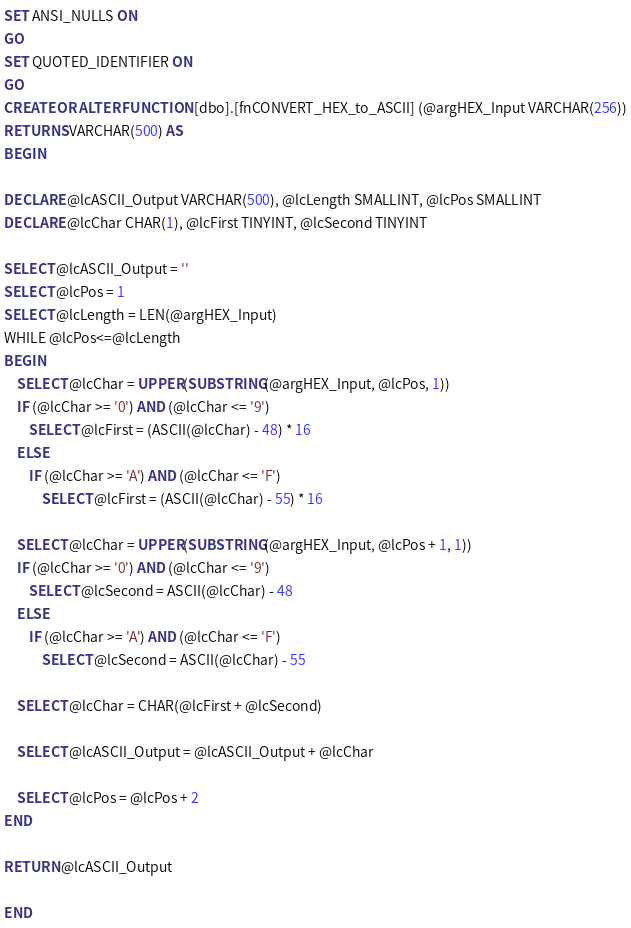Convert code to text. <code><loc_0><loc_0><loc_500><loc_500><_SQL_>SET ANSI_NULLS ON
GO
SET QUOTED_IDENTIFIER ON
GO
CREATE OR ALTER FUNCTION [dbo].[fnCONVERT_HEX_to_ASCII] (@argHEX_Input VARCHAR(256))
RETURNS VARCHAR(500) AS  
BEGIN 

DECLARE @lcASCII_Output VARCHAR(500), @lcLength SMALLINT, @lcPos SMALLINT
DECLARE @lcChar CHAR(1), @lcFirst TINYINT, @lcSecond TINYINT

SELECT @lcASCII_Output = ''
SELECT @lcPos = 1
SELECT @lcLength = LEN(@argHEX_Input)
WHILE @lcPos<=@lcLength
BEGIN
	SELECT @lcChar = UPPER(SUBSTRING(@argHEX_Input, @lcPos, 1))
	IF (@lcChar >= '0') AND (@lcChar <= '9') 
		SELECT @lcFirst = (ASCII(@lcChar) - 48) * 16
	ELSE
		IF (@lcChar >= 'A') AND (@lcChar <= 'F') 
			SELECT @lcFirst = (ASCII(@lcChar) - 55) * 16

	SELECT @lcChar = UPPER(SUBSTRING(@argHEX_Input, @lcPos + 1, 1))
	IF (@lcChar >= '0') AND (@lcChar <= '9') 
		SELECT @lcSecond = ASCII(@lcChar) - 48
	ELSE
		IF (@lcChar >= 'A') AND (@lcChar <= 'F') 
			SELECT @lcSecond = ASCII(@lcChar) - 55

	SELECT @lcChar = CHAR(@lcFirst + @lcSecond)

	SELECT @lcASCII_Output = @lcASCII_Output + @lcChar

	SELECT @lcPos = @lcPos + 2
END

RETURN @lcASCII_Output

END
</code> 